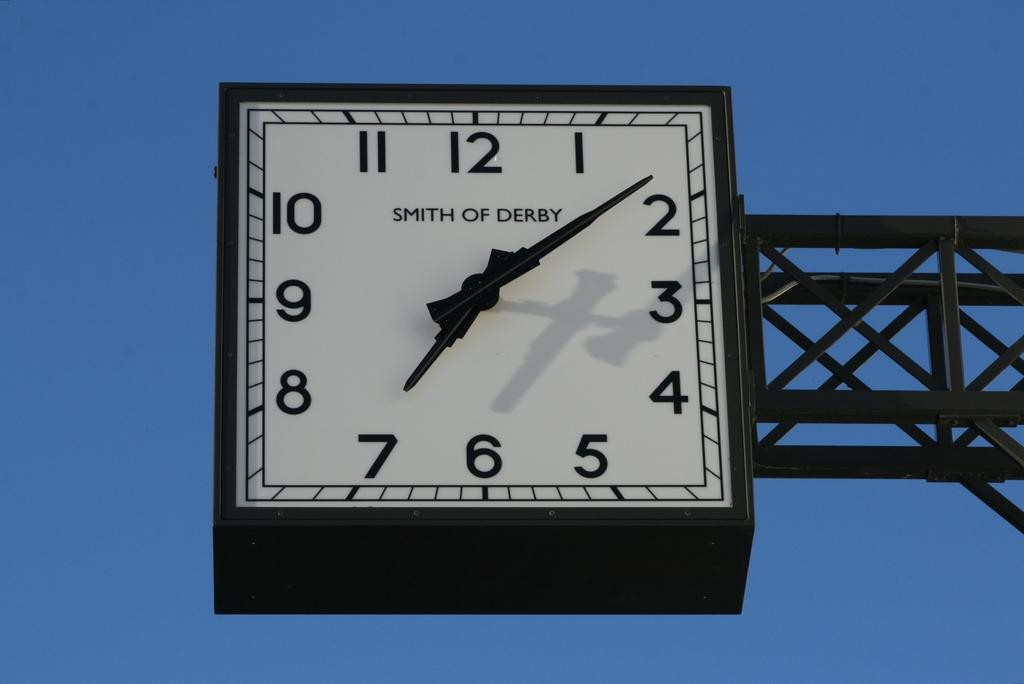Provide a one-sentence caption for the provided image. A square clock manufactured by Smith of Derby shows the time as 7:08. 